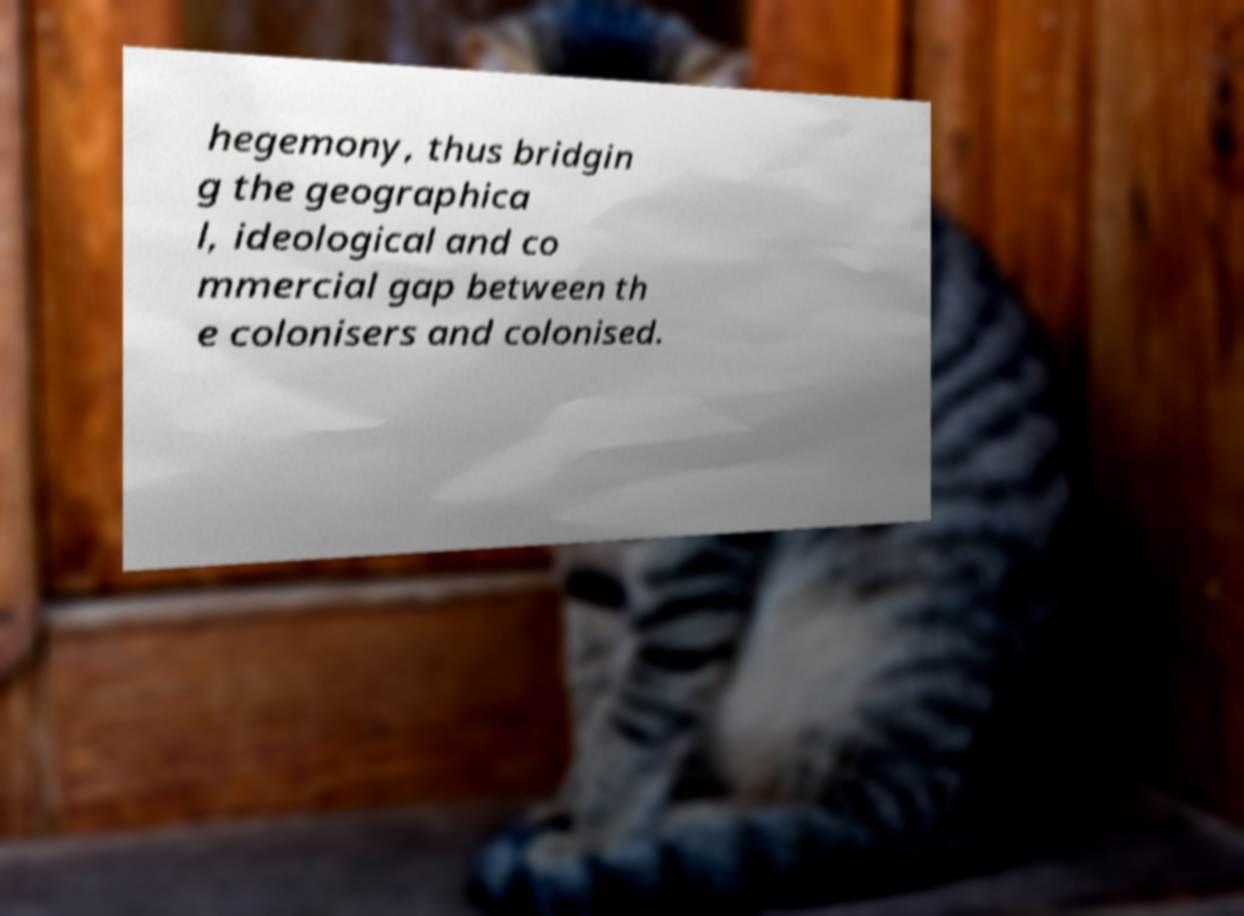Could you assist in decoding the text presented in this image and type it out clearly? hegemony, thus bridgin g the geographica l, ideological and co mmercial gap between th e colonisers and colonised. 